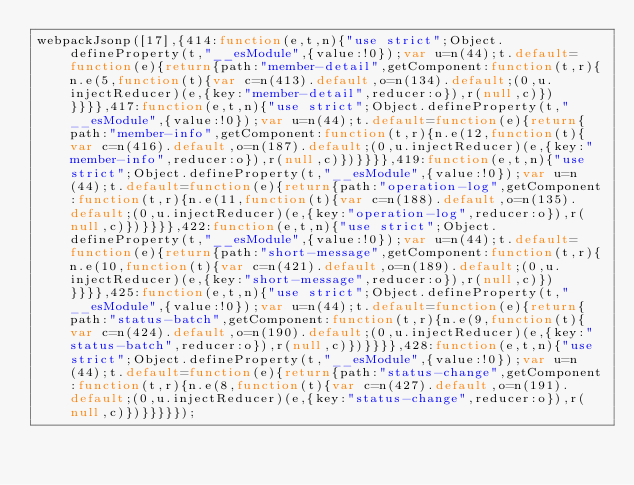Convert code to text. <code><loc_0><loc_0><loc_500><loc_500><_JavaScript_>webpackJsonp([17],{414:function(e,t,n){"use strict";Object.defineProperty(t,"__esModule",{value:!0});var u=n(44);t.default=function(e){return{path:"member-detail",getComponent:function(t,r){n.e(5,function(t){var c=n(413).default,o=n(134).default;(0,u.injectReducer)(e,{key:"member-detail",reducer:o}),r(null,c)})}}}},417:function(e,t,n){"use strict";Object.defineProperty(t,"__esModule",{value:!0});var u=n(44);t.default=function(e){return{path:"member-info",getComponent:function(t,r){n.e(12,function(t){var c=n(416).default,o=n(187).default;(0,u.injectReducer)(e,{key:"member-info",reducer:o}),r(null,c)})}}}},419:function(e,t,n){"use strict";Object.defineProperty(t,"__esModule",{value:!0});var u=n(44);t.default=function(e){return{path:"operation-log",getComponent:function(t,r){n.e(11,function(t){var c=n(188).default,o=n(135).default;(0,u.injectReducer)(e,{key:"operation-log",reducer:o}),r(null,c)})}}}},422:function(e,t,n){"use strict";Object.defineProperty(t,"__esModule",{value:!0});var u=n(44);t.default=function(e){return{path:"short-message",getComponent:function(t,r){n.e(10,function(t){var c=n(421).default,o=n(189).default;(0,u.injectReducer)(e,{key:"short-message",reducer:o}),r(null,c)})}}}},425:function(e,t,n){"use strict";Object.defineProperty(t,"__esModule",{value:!0});var u=n(44);t.default=function(e){return{path:"status-batch",getComponent:function(t,r){n.e(9,function(t){var c=n(424).default,o=n(190).default;(0,u.injectReducer)(e,{key:"status-batch",reducer:o}),r(null,c)})}}}},428:function(e,t,n){"use strict";Object.defineProperty(t,"__esModule",{value:!0});var u=n(44);t.default=function(e){return{path:"status-change",getComponent:function(t,r){n.e(8,function(t){var c=n(427).default,o=n(191).default;(0,u.injectReducer)(e,{key:"status-change",reducer:o}),r(null,c)})}}}}});</code> 